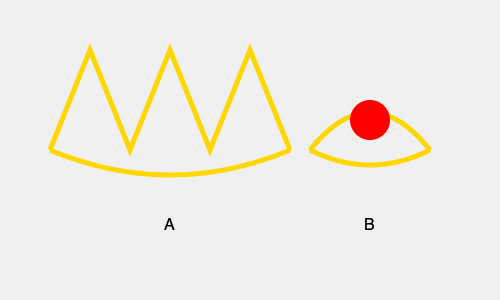Examine the two crown designs labeled A and B. Which of these crowns is most likely associated with the British monarchy, and what key feature distinguishes it? To identify the crown associated with the British monarchy and its distinguishing feature, let's analyze both crowns:

1. Crown A:
   - Features multiple peaks and valleys
   - Has a more elaborate design with 5 visible points
   - The shape resembles the St. Edward's Crown, used in British coronations

2. Crown B:
   - Has a simpler, curved design
   - Features a large, prominent jewel (likely a ruby) at the center
   - Resembles the shape of the French Crown Jewels

3. Key distinguishing features of the British crown (Crown A):
   - The alternating cross pattée and fleur-de-lis design (represented by the peaks)
   - The arches that rise from the base to the top
   - The overall shape, which is more squared and less rounded than many continental European crowns

4. Historical context:
   - The St. Edward's Crown, which Crown A resembles, has been used in British coronations since the 17th century
   - Its design is iconic and instantly recognizable as a symbol of the British monarchy

Based on these observations, Crown A is most likely associated with the British monarchy, and its key distinguishing feature is the alternating peaks representing the cross pattée and fleur-de-lis design.
Answer: Crown A; alternating cross pattée and fleur-de-lis design 